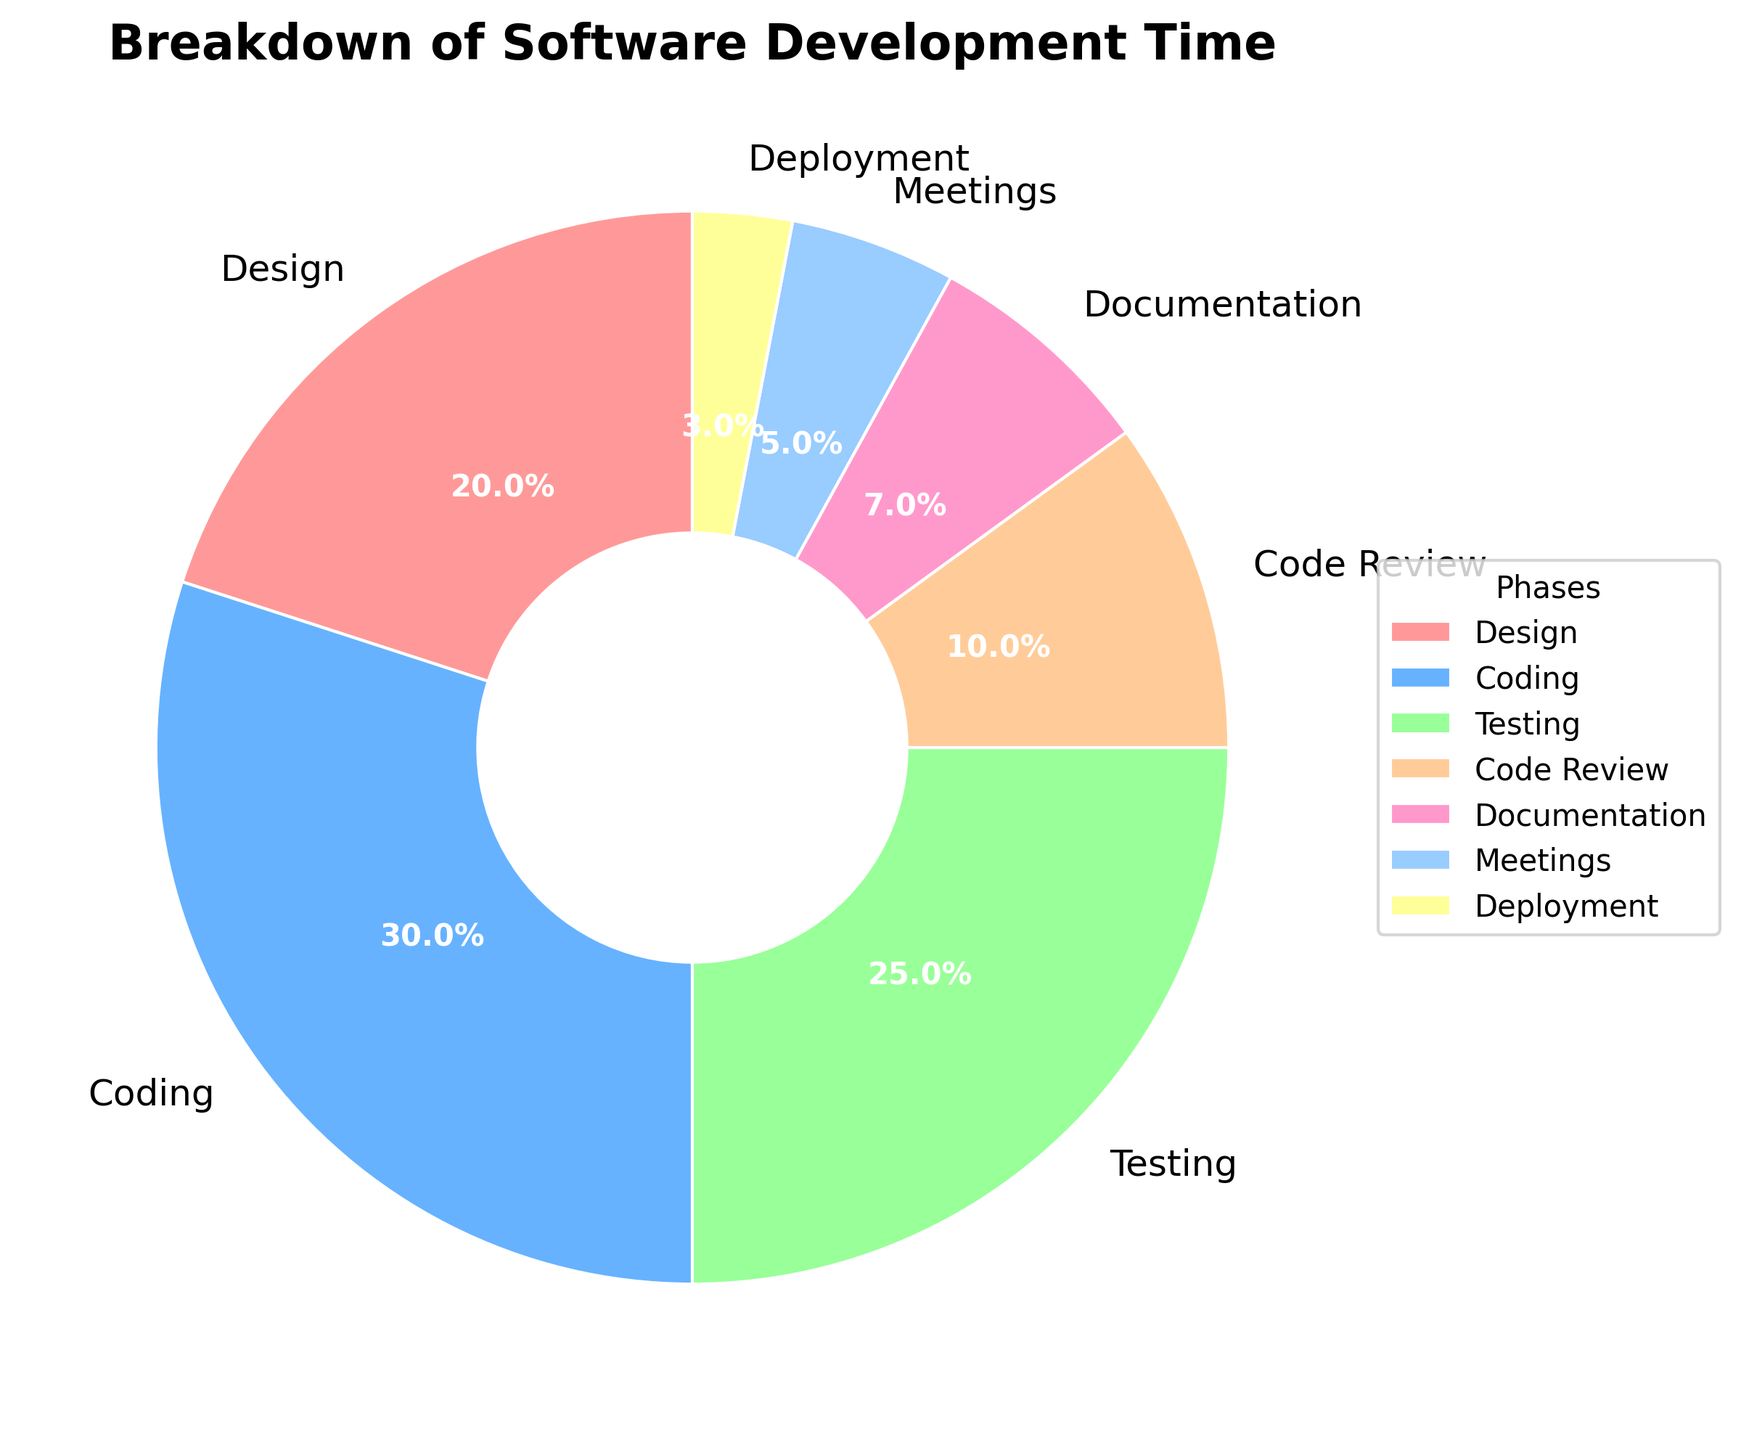What percentage of the total development time is spent on Coding and Testing combined? Add the percentages of Coding (30%) and Testing (25%) together: 30% + 25% = 55%
Answer: 55% Which phase occupies the smallest percentage of the development time? Identify the phase with the smallest value from the pie chart; Deployment has 3%, which is the smallest.
Answer: Deployment How much more time is spent on Design compared to Code Review? Subtract the percentage of Code Review (10%) from Design (20%): 20% - 10% = 10%
Answer: 10% Is more time spent on Meetings or Documentation? By how much? Compare the percentages: Documentation (7%) and Meetings (5%). More time is spent on Documentation. The difference is 7% - 5% = 2%
Answer: Documentation, 2% What proportion of the total development time is spent on activities other than Coding? Subtract the percentage for Coding (30%) from 100% since Coding represents part of the activities: 100% - 30% = 70%
Answer: 70% What is the average percentage of the phases that are not Testing, Code Review, and Deployment? Sum the percentages of the non-included phases and divide by the number of phases: (20% + 30% + 7% + 5%) / 4 = 62% / 4 = 15.5%
Answer: 15.5% What is the ratio of time spent on Coding to the time spent on Documentation? Divide the percentage for Coding (30%) by the percentage for Documentation (7%): 30 / 7 ≈ 4.29
Answer: 4.29 If the time spent on Documentation were doubled, would it take more or less time than Testing? Double the percentage for Documentation: 7% * 2 = 14%. Compare 14% with Testing 25%. Testing would still take more time than Documentation
Answer: Less Are there more phases with a percentage of 10% or more, or less than 10%? Count the phases with 10% or more (Design, Coding, Testing, Code Review: 4 phases) and less than 10% (Documentation, Meetings, Deployment: 3 phases). There are more phases with 10% or more.
Answer: More If the percentage of time spent in Coding were reduced by 5% and added to Deployment, would Deployment still have the smallest percentage? Decrease Coding by 5%: 30% - 5% = 25%. Increase Deployment by 5%: 3% + 5% = 8%. The new smallest percentage would be Meetings at 5%.
Answer: No 